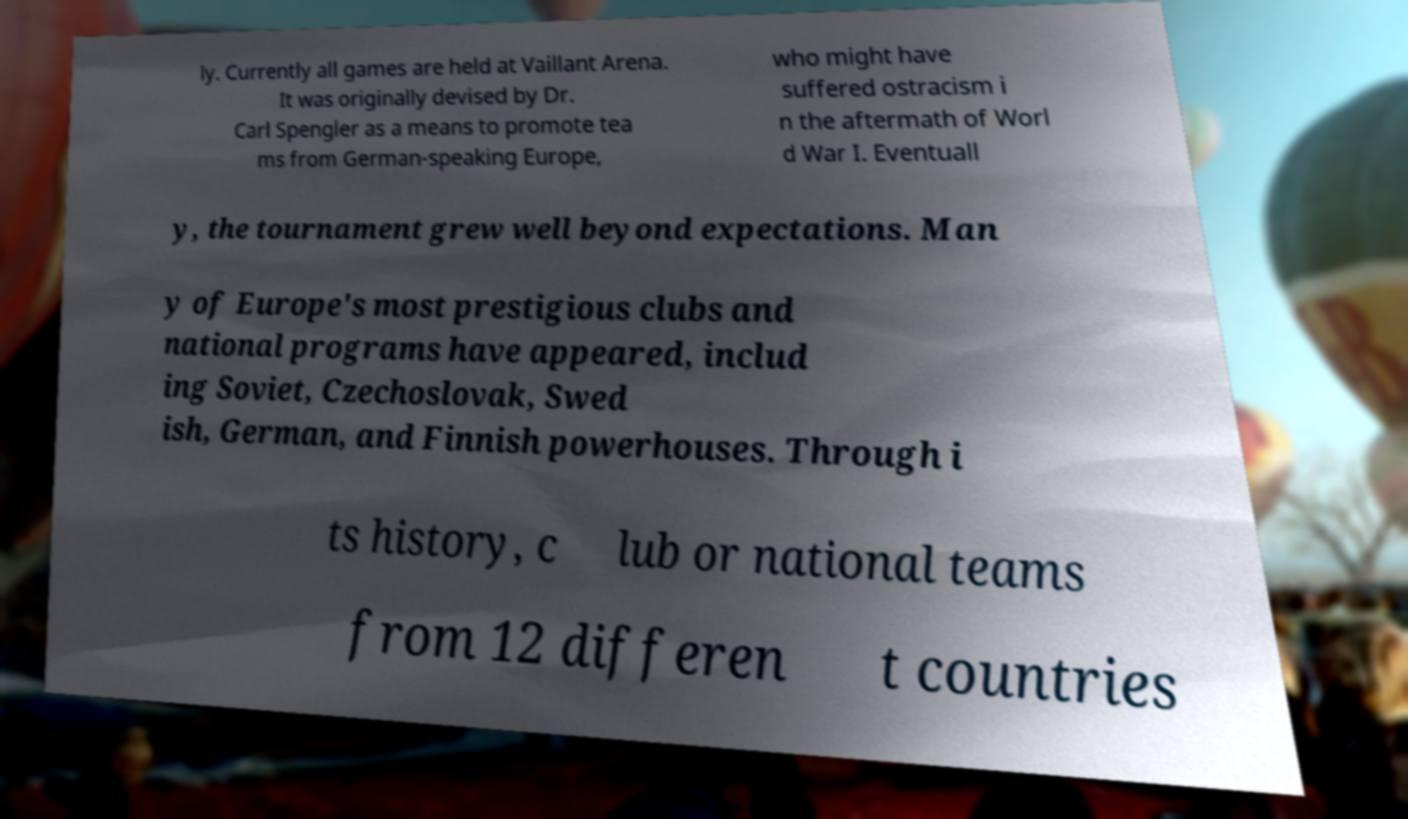Please read and relay the text visible in this image. What does it say? ly. Currently all games are held at Vaillant Arena. It was originally devised by Dr. Carl Spengler as a means to promote tea ms from German-speaking Europe, who might have suffered ostracism i n the aftermath of Worl d War I. Eventuall y, the tournament grew well beyond expectations. Man y of Europe's most prestigious clubs and national programs have appeared, includ ing Soviet, Czechoslovak, Swed ish, German, and Finnish powerhouses. Through i ts history, c lub or national teams from 12 differen t countries 